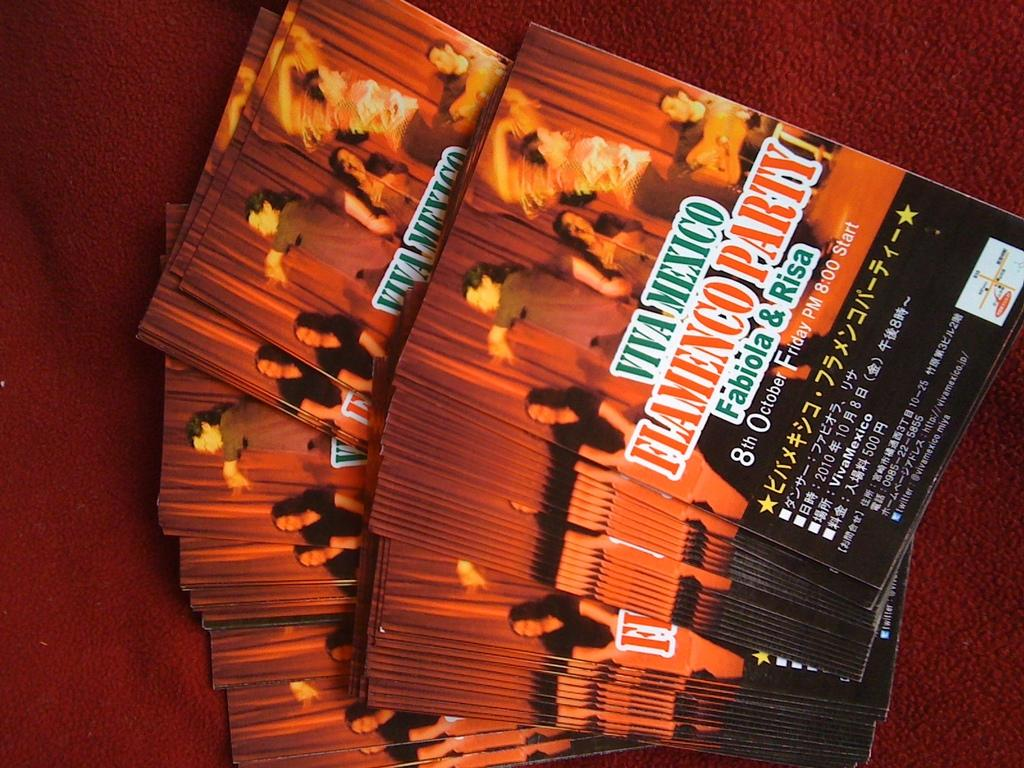What is the main subject of the image? The main subject of the image is a collection of books. How are the books arranged in the image? The books are placed on a maroon cloth. What can be seen on the cover pages of the books? The cover pages of the books have images and text. What type of land can be seen in the image? There is no land visible in the image; it features a collection of books placed on a maroon cloth. What reason might the books be placed on the maroon cloth? The reason for placing the books on the maroon cloth is not mentioned in the image, so it cannot be determined from the image alone. 